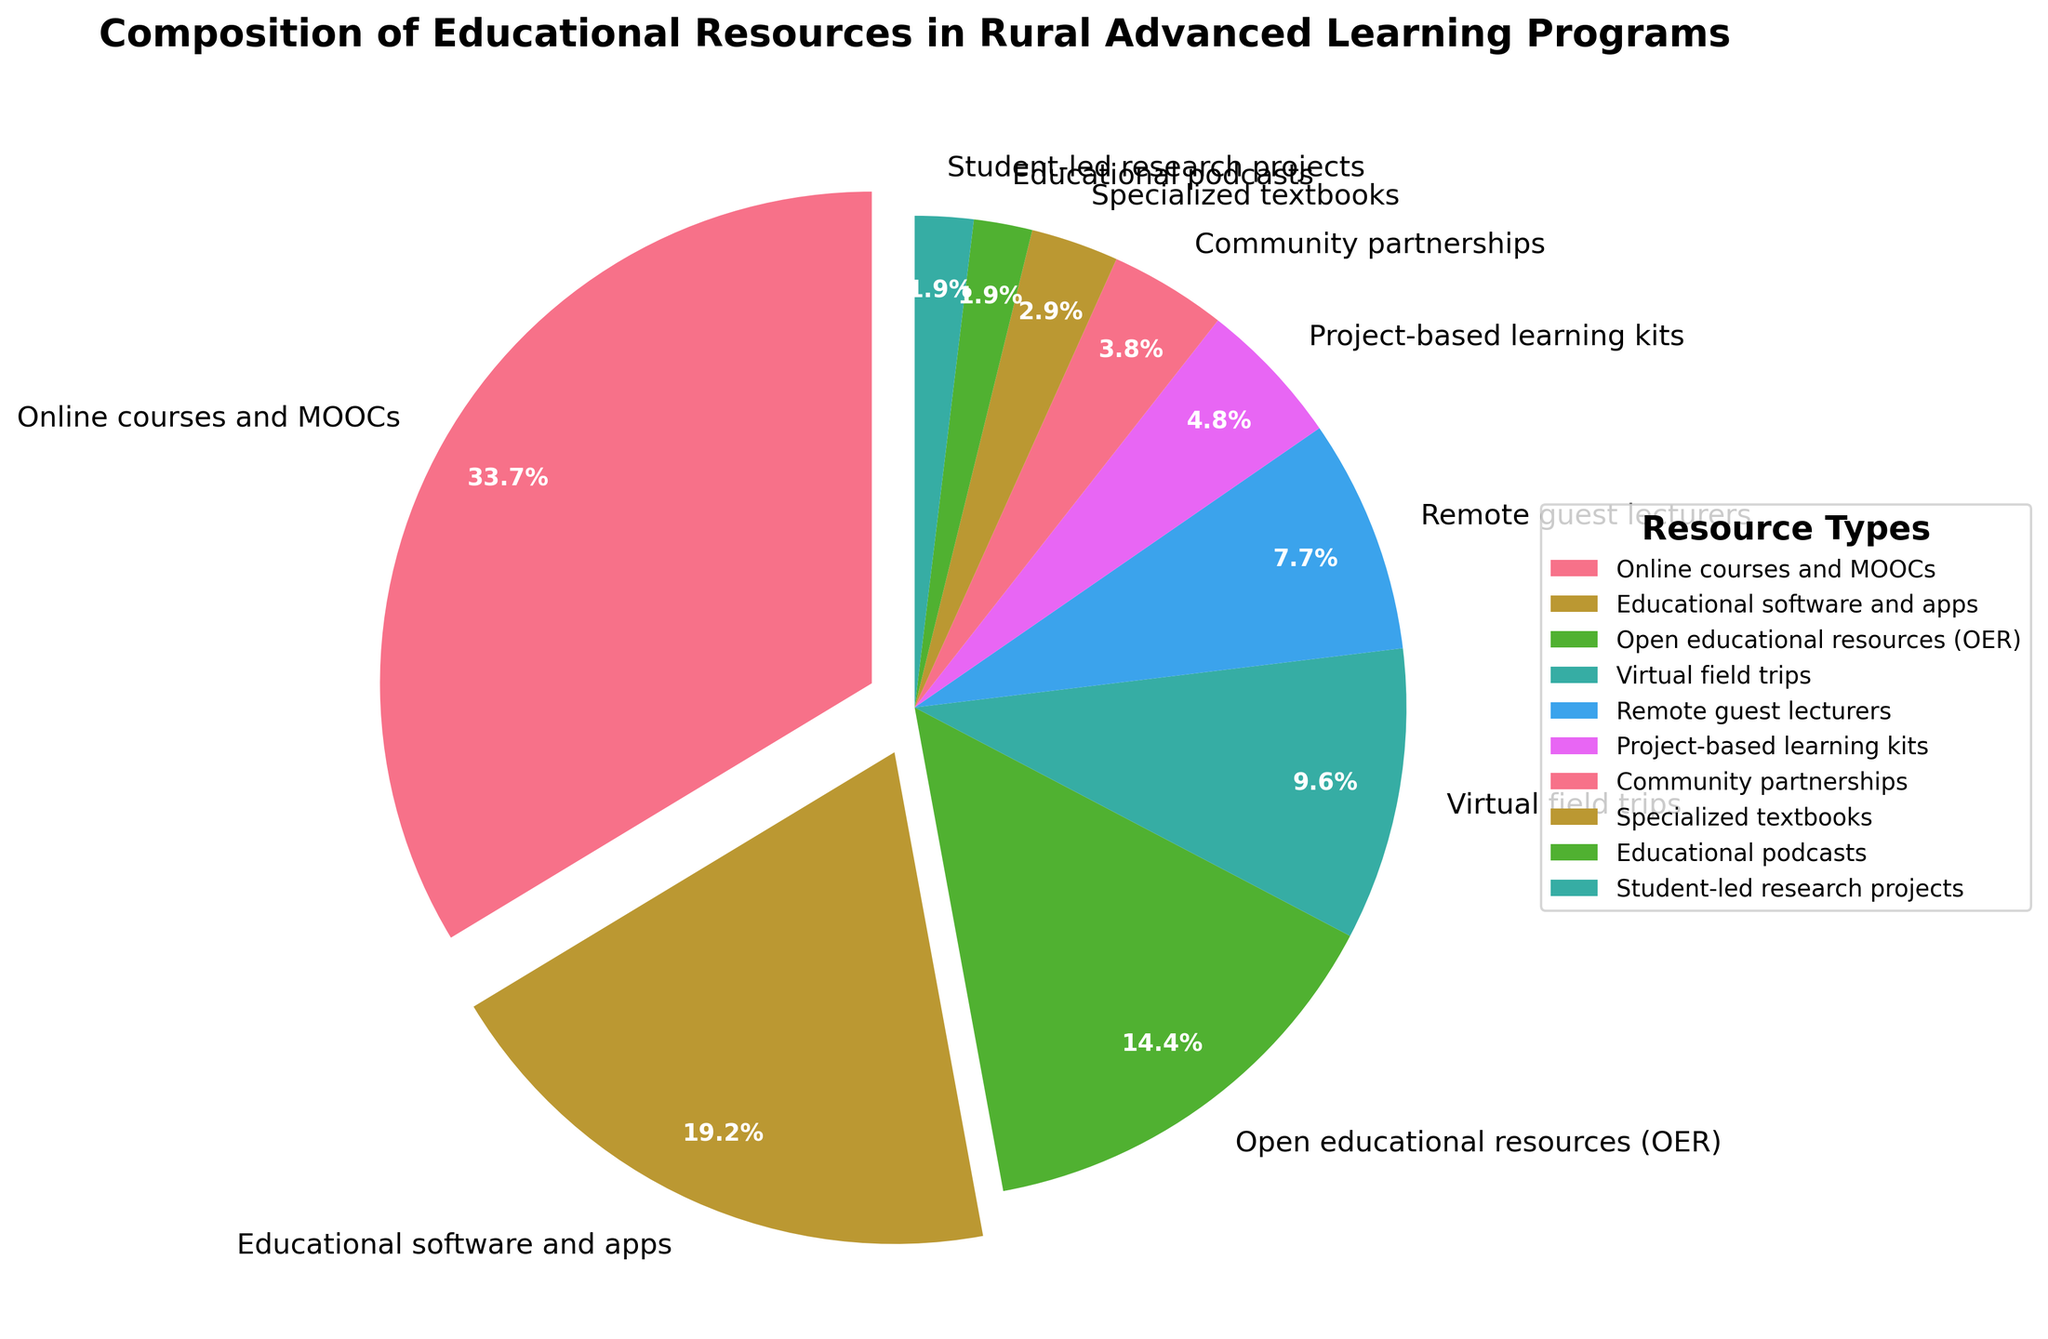What percentage of educational resources in rural advanced learning programs are made up by the top three resource types? Sum the percentages of the top three resource types: Online courses and MOOCs (35%), Educational software and apps (20%), and Open educational resources (15%). So, 35 + 20 + 15 = 70%.
Answer: 70% Which resource type has the smallest representation, and what is its percentage? Identify the lowest percentage in the data table, which corresponds to Educational podcasts and Student-led research projects, each at 2%.
Answer: Educational podcasts and Student-led research projects, 2% Is the combined percentage of Project-based learning kits and Community partnerships greater than that of Remote guest lecturers? Sum the percentages for Project-based learning kits (5%) and Community partnerships (4%), which yields 5 + 4 = 9%. Compare this to the percentage for Remote guest lecturers (8%). Yes, 9% > 8%.
Answer: Yes, 9% > 8% Compare the percentages of Online courses and MOOCs to Specialized textbooks. How many times greater is the former? Divide the percentage of Online courses and MOOCs (35%) by that of Specialized textbooks (3%). 35 / 3 ≈ 11.67. So, Online courses and MOOCs are approximately 11.67 times greater than Specialized textbooks.
Answer: ≈ 11.67 times If we were to combine Virtual field trips, Remote guest lecturers, and Community partnerships, what would be their total percentage? Sum the percentages for Virtual field trips (10%), Remote guest lecturers (8%), and Community partnerships (4%). So, 10 + 8 + 4 = 22%.
Answer: 22% Which resource types together make up exactly a quarter (25%) of the composition when summed? Look for resource types whose total percentage adds up to 25%. Educational software and apps (20%) and Specialized textbooks (3%) together are 23%, but if we include Educational podcasts (2%), we get 20 + 3 + 2 = 25%.
Answer: Educational software and apps, Specialized textbooks, Educational podcasts What is the difference in percentages between the most utilized and least utilized resource types? Subtract the smallest percentage (2% for both Educational podcasts and Student-led research projects) from the largest percentage (35% for Online courses and MOOCs). 35 - 2 = 33%.
Answer: 33% How much more popular are Open educational resources than Project-based learning kits? Subtract the percentage of Project-based learning kits (5%) from that of Open educational resources (15%). 15 - 5 = 10%.
Answer: 10% What percentage of the total is accounted for by non-digital resources (Community partnerships, Specialized textbooks, and Project-based learning kits)? Sum the percentages for Community partnerships (4%), Specialized textbooks (3%), and Project-based learning kits (5%). So, 4 + 3 + 5 = 12%.
Answer: 12% If another resource type, not currently listed, were introduced with a representation of 10%, how would that alter the current highest percentage resource's share, assuming scaled percentages are recalculated? The total percentage before adding the new resource is 100%. Adding a new resource with a 10% share will result in a new total of 110%. Recalculated share for Online courses and MOOCs would be (35/110)*100 ≈ 31.82%.
Answer: ≈ 31.82% 